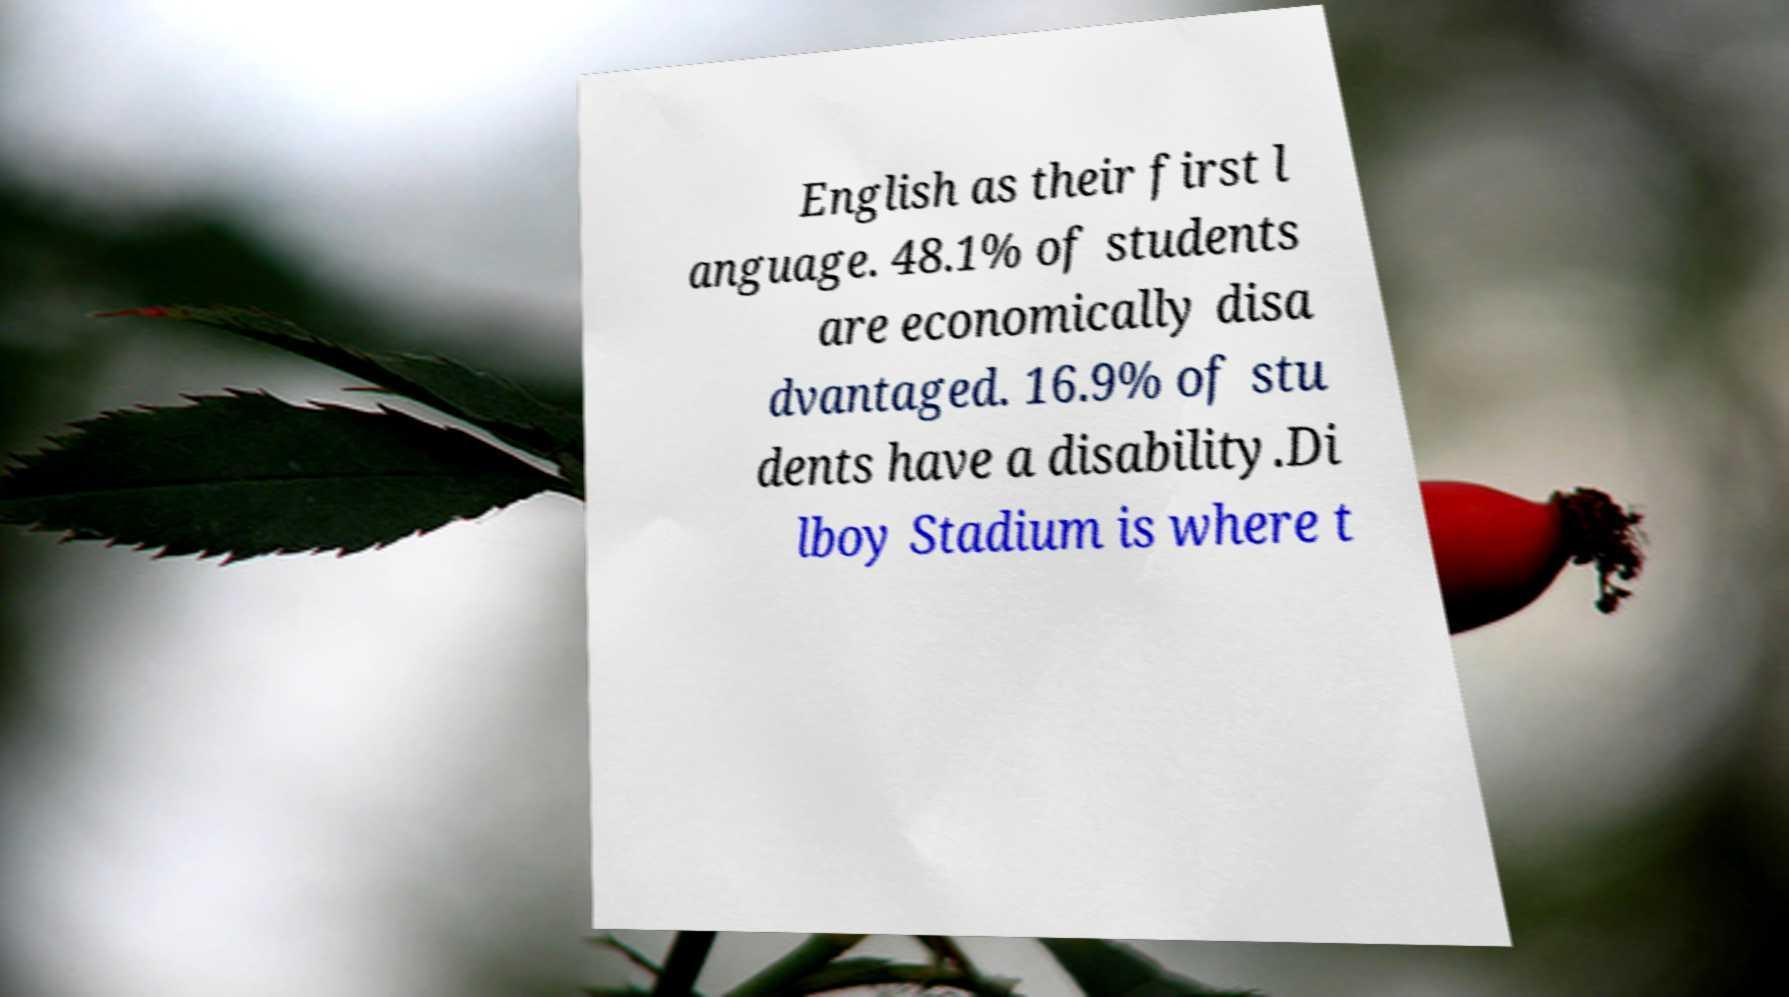There's text embedded in this image that I need extracted. Can you transcribe it verbatim? English as their first l anguage. 48.1% of students are economically disa dvantaged. 16.9% of stu dents have a disability.Di lboy Stadium is where t 